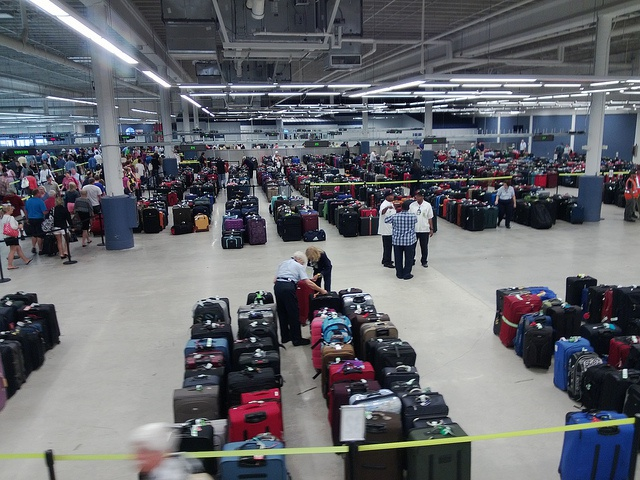Describe the objects in this image and their specific colors. I can see suitcase in purple, black, gray, and darkgray tones, people in purple, black, gray, darkgray, and navy tones, suitcase in purple, navy, black, blue, and darkblue tones, people in purple, black, darkgray, and lightgray tones, and people in purple, black, darkgray, and gray tones in this image. 